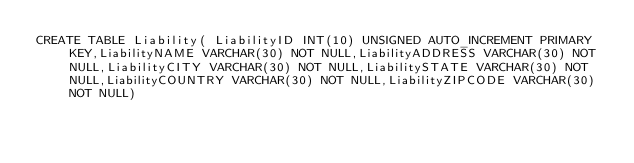Convert code to text. <code><loc_0><loc_0><loc_500><loc_500><_SQL_>CREATE TABLE Liability( LiabilityID INT(10) UNSIGNED AUTO_INCREMENT PRIMARY KEY,LiabilityNAME VARCHAR(30) NOT NULL,LiabilityADDRESS VARCHAR(30) NOT NULL,LiabilityCITY VARCHAR(30) NOT NULL,LiabilitySTATE VARCHAR(30) NOT NULL,LiabilityCOUNTRY VARCHAR(30) NOT NULL,LiabilityZIPCODE VARCHAR(30) NOT NULL)

</code> 